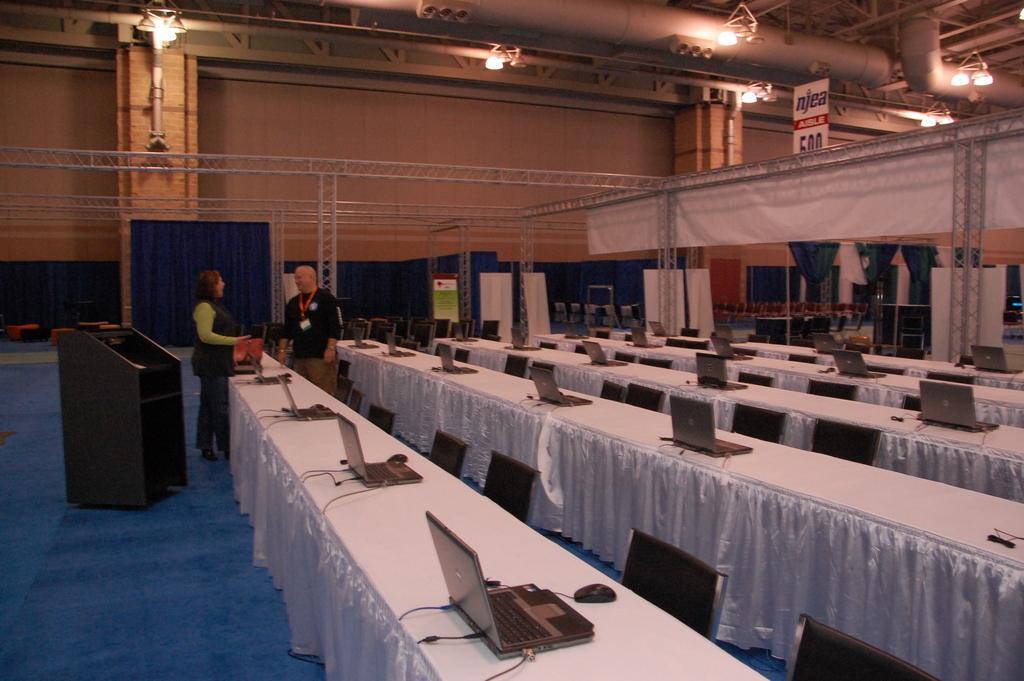Can you describe this image briefly? In this image we can see two people standing. There are tables and we can see laptops placed on the tables. On the left there is a podium and we can see chairs. In the background there are curtains and wall. There is a board. At the top there are lights. 